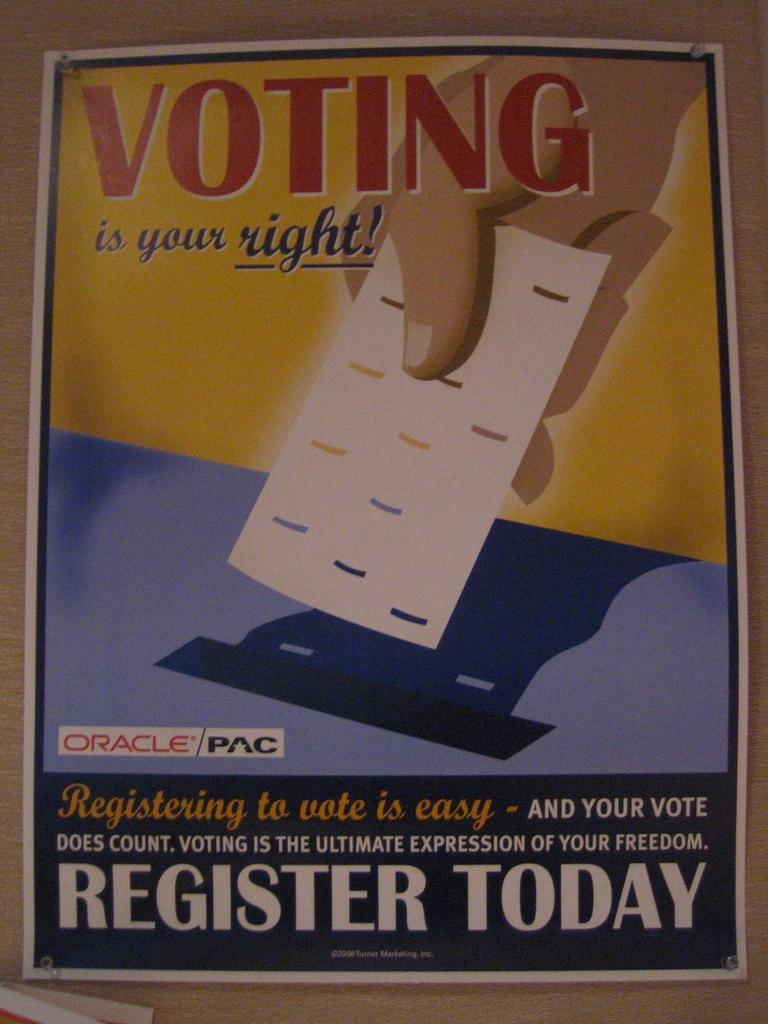<image>
Offer a succinct explanation of the picture presented. A poster to recruit voters states that it is your right. 